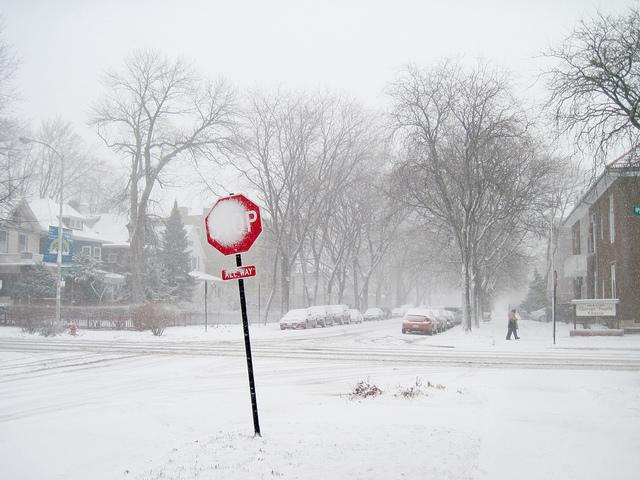Is it cold outside?
Write a very short answer. Yes. Is the stop sign covered with snow?
Give a very brief answer. Yes. Is there a snow storm?
Concise answer only. Yes. 